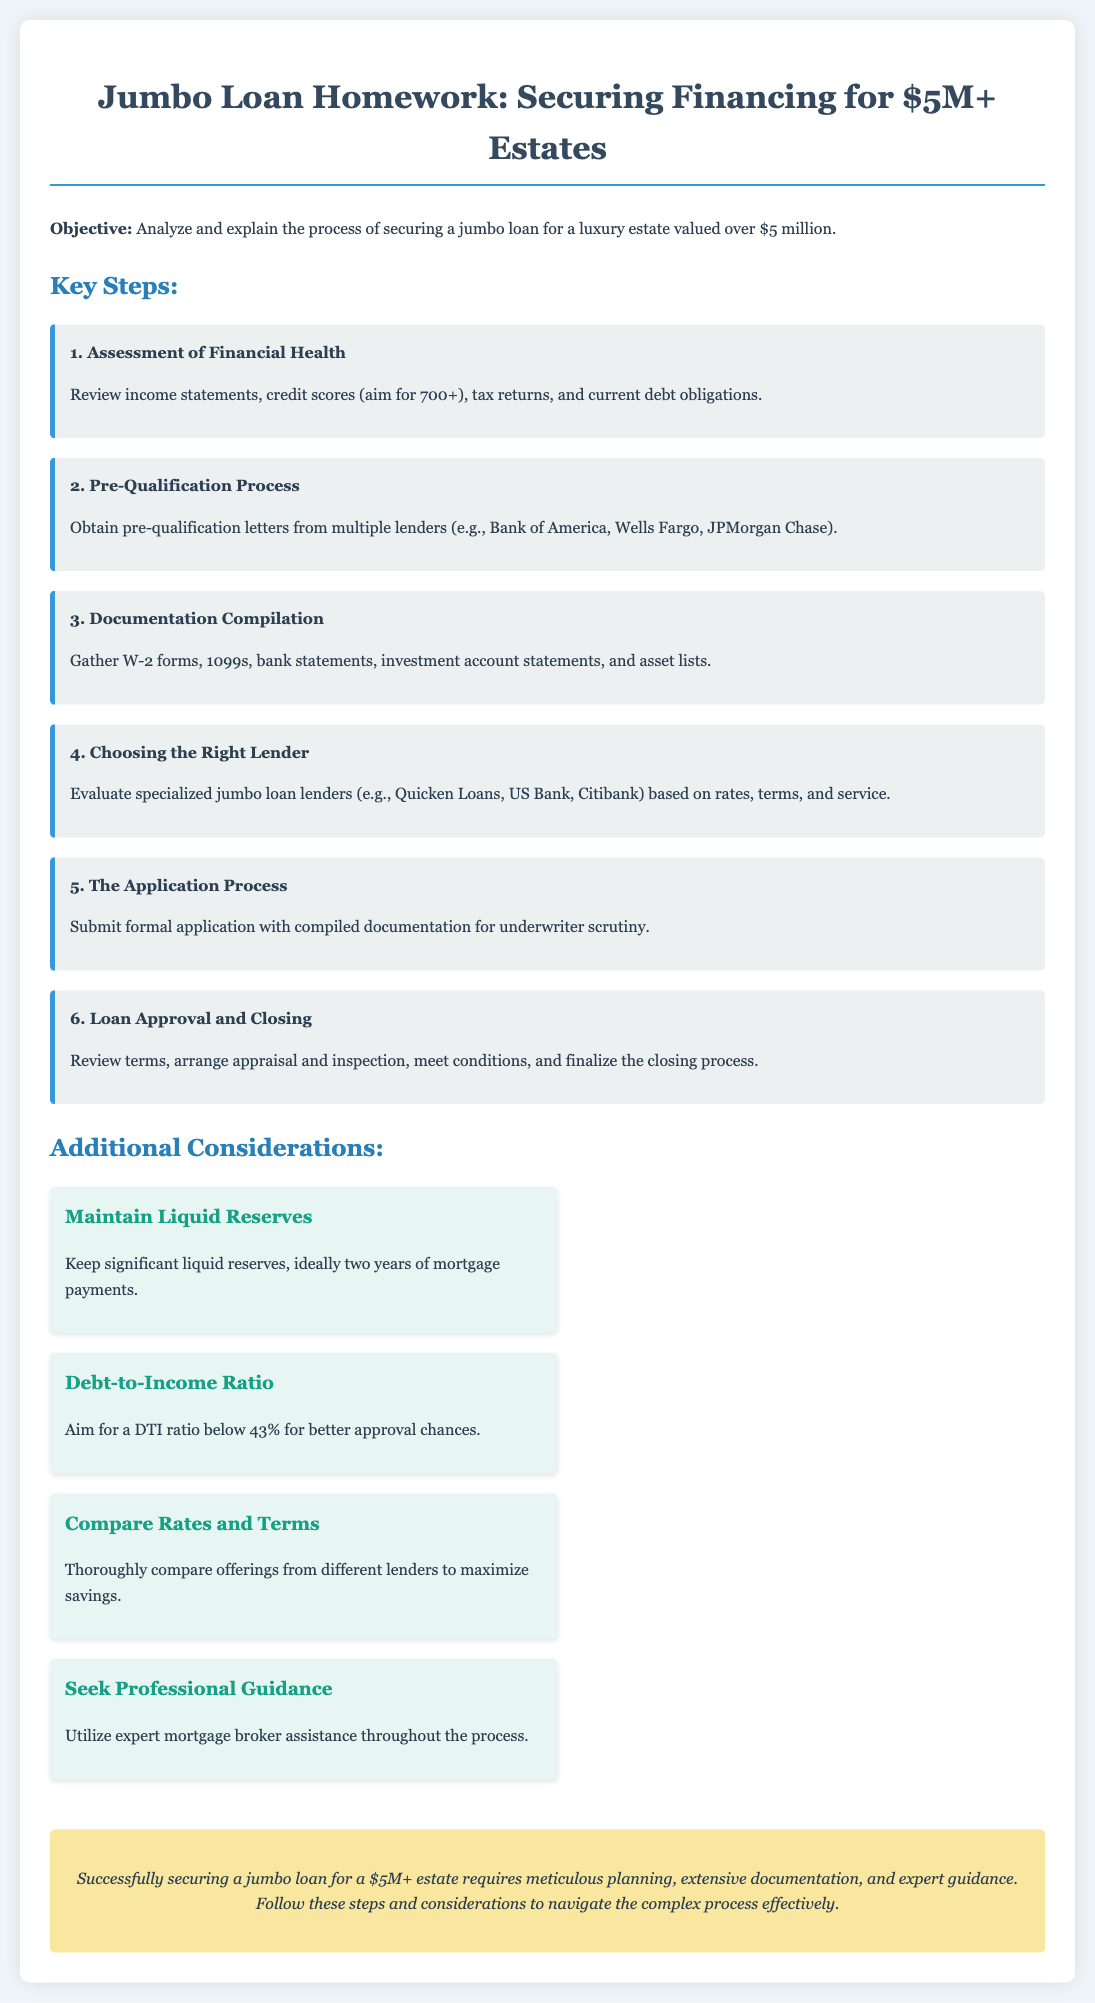What is the main objective of the document? The document aims to analyze and explain the process of securing a jumbo loan for a luxury estate valued over $5 million.
Answer: Analyze and explain the process of securing a jumbo loan for a luxury estate valued over $5 million What credit score does one aim for when assessing financial health? The document states that one should aim for a credit score of 700 or higher during the financial health assessment.
Answer: 700+ Which lenders are suggested for obtaining pre-qualification letters? Multiple lenders including Bank of America, Wells Fargo, and JPMorgan Chase are mentioned for obtaining pre-qualification letters.
Answer: Bank of America, Wells Fargo, JPMorgan Chase What is the ideal debt-to-income ratio for better approval chances? The document advises aiming for a debt-to-income ratio below 43% to improve chances of approval.
Answer: Below 43% What is the first step in the key steps to secure a jumbo loan? The initial step described in the document is the assessment of financial health.
Answer: Assessment of Financial Health Which type of lenders should be evaluated when choosing a lender? Specialized jumbo loan lenders like Quicken Loans, US Bank, and Citibank should be evaluated according to the document.
Answer: Quicken Loans, US Bank, Citibank How many years of liquid reserves should one maintain? The document recommends keeping significant liquid reserves, ideally two years of mortgage payments.
Answer: Two years What is emphasized as a crucial consideration throughout the process? The document highlights seeking professional guidance as an important consideration throughout the process of securing a jumbo loan.
Answer: Seek Professional Guidance 